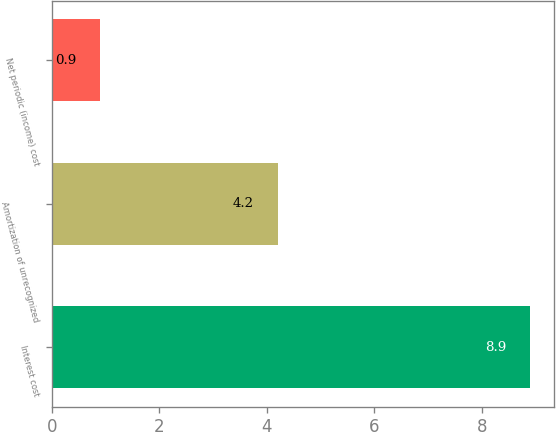<chart> <loc_0><loc_0><loc_500><loc_500><bar_chart><fcel>Interest cost<fcel>Amortization of unrecognized<fcel>Net periodic (income) cost<nl><fcel>8.9<fcel>4.2<fcel>0.9<nl></chart> 